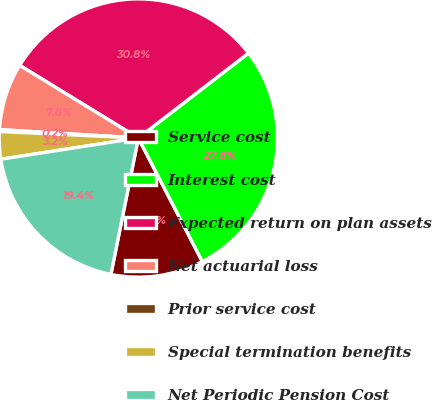<chart> <loc_0><loc_0><loc_500><loc_500><pie_chart><fcel>Service cost<fcel>Interest cost<fcel>Expected return on plan assets<fcel>Net actuarial loss<fcel>Prior service cost<fcel>Special termination benefits<fcel>Net Periodic Pension Cost<nl><fcel>10.77%<fcel>27.84%<fcel>30.8%<fcel>7.78%<fcel>0.22%<fcel>3.18%<fcel>19.4%<nl></chart> 